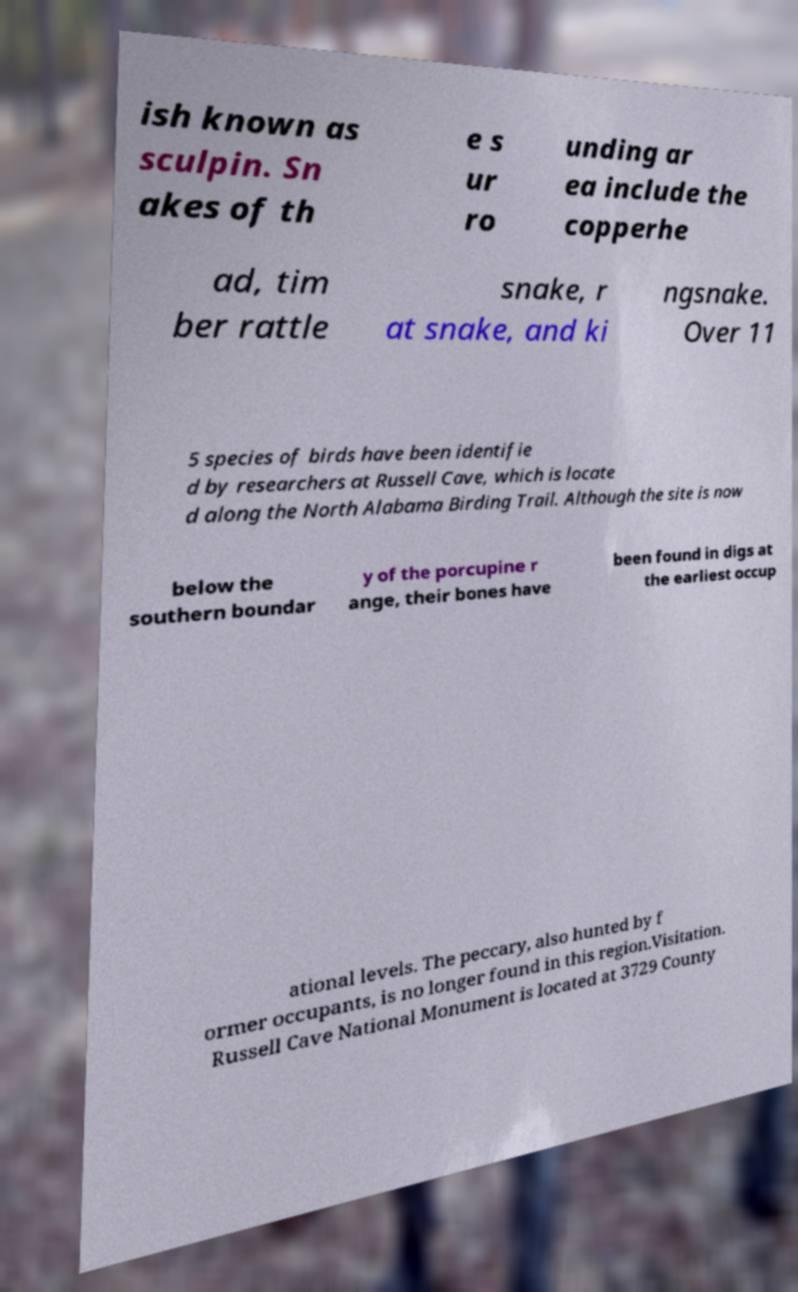What messages or text are displayed in this image? I need them in a readable, typed format. ish known as sculpin. Sn akes of th e s ur ro unding ar ea include the copperhe ad, tim ber rattle snake, r at snake, and ki ngsnake. Over 11 5 species of birds have been identifie d by researchers at Russell Cave, which is locate d along the North Alabama Birding Trail. Although the site is now below the southern boundar y of the porcupine r ange, their bones have been found in digs at the earliest occup ational levels. The peccary, also hunted by f ormer occupants, is no longer found in this region.Visitation. Russell Cave National Monument is located at 3729 County 